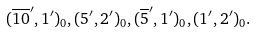<formula> <loc_0><loc_0><loc_500><loc_500>( \overline { 1 0 } ^ { \prime } , { 1 } ^ { \prime } ) _ { 0 } , ( { 5 } ^ { \prime } , { 2 } ^ { \prime } ) _ { 0 } , ( \overline { 5 } ^ { \prime } , { 1 } ^ { \prime } ) _ { 0 } , ( { 1 } ^ { \prime } , { 2 } ^ { \prime } ) _ { 0 } .</formula> 